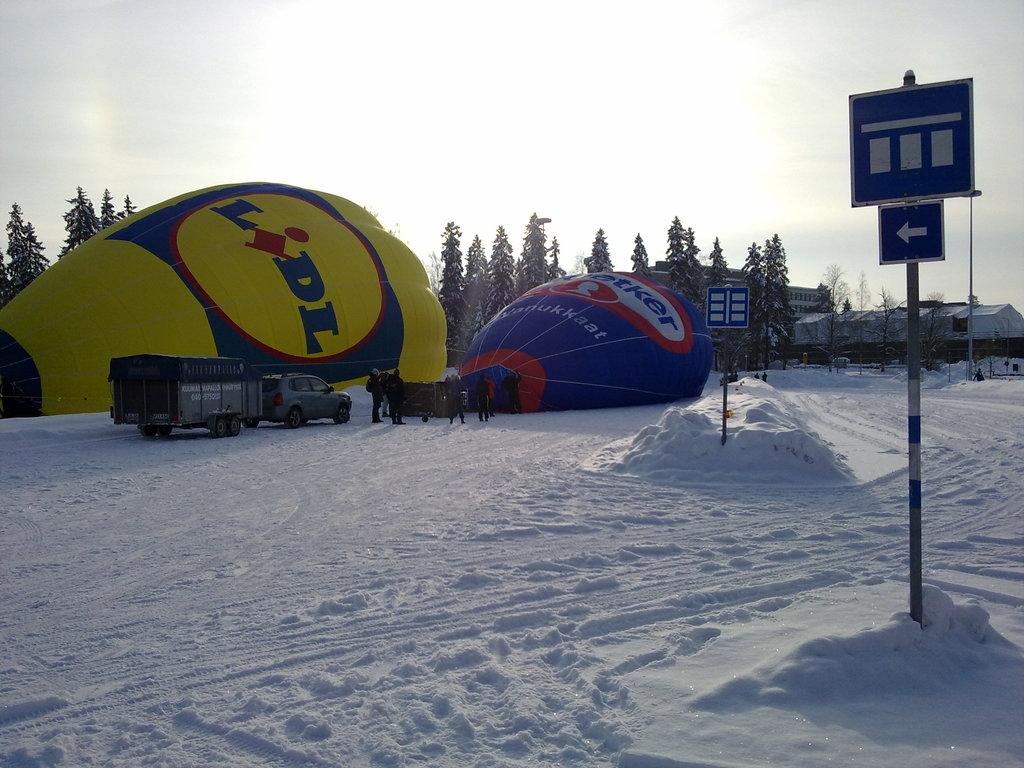What objects are related to jumping or descending in the image? There are parachutes in the image. What type of vehicle is present in the image? There is a vehicle in the image. What are the people on the snow doing? The people on the snow are likely engaging in winter sports or activities. What type of signs can be seen in the image? Sign boards are present in the image. What structures are visible in the image? Poles are visible in the image. What can be seen in the background of the image? There are trees, houses, and the sky visible in the background of the image. Where are the chickens located in the image? There are no chickens present in the image. What type of badge is being worn by the people on the snow? There is no mention of badges or any type of identification in the image. 